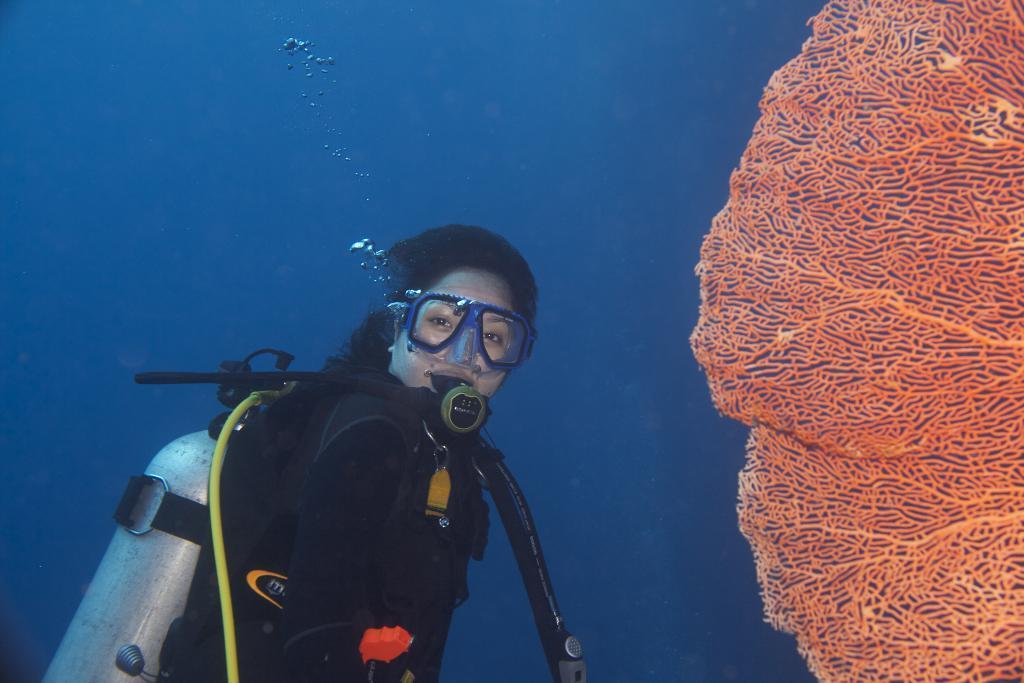Please provide a concise description of this image. The woman in black jacket is scuba diving. Beside her, we see a net in orange color. In the background, it is blue in color. 